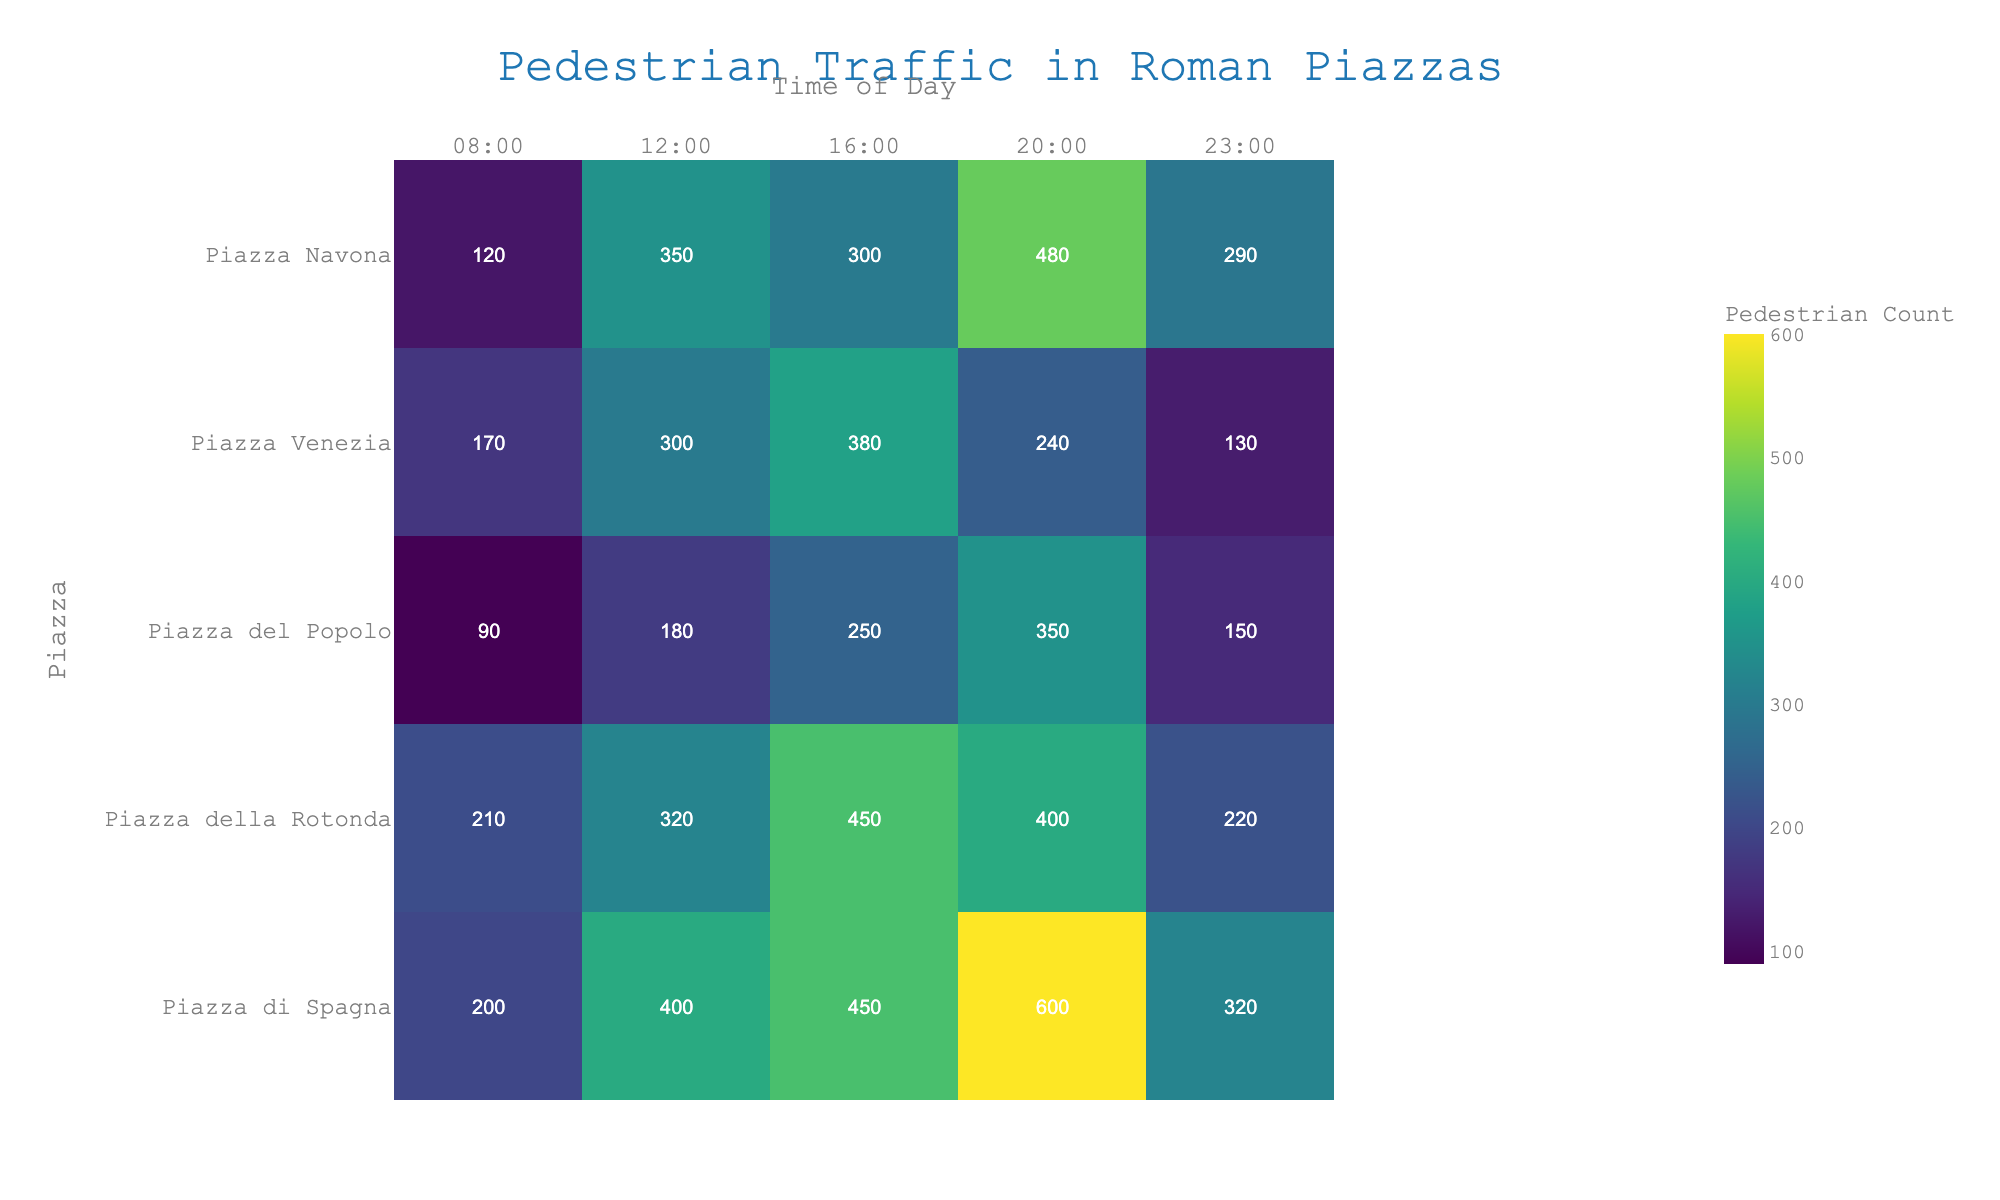What is the pedestrian count in Piazza Navona at 12:00? Look at the intersection of the row for Piazza Navona and the column for 12:00 in the heatmap.
Answer: 350 Which piazza has the highest pedestrian count at 20:00? Compare the values in the column for 20:00 across all piazzas. The highest value is 600 at Piazza di Spagna.
Answer: Piazza di Spagna What is the difference in pedestrian count between Piazza Navona and Piazza Venezia at 16:00? Subtract the pedestrian count of Piazza Venezia from Piazza Navona at 16:00 (300 - 380).
Answer: -80 Which piazza has the lowest pedestrian count at 08:00? Look for the smallest value in the column for 08:00. The lowest value is 90 at Piazza del Popolo.
Answer: Piazza del Popolo What is the average pedestrian count in Piazza della Rotonda throughout the day? Add up all the counts for Piazza della Rotonda and divide by the number of time points (210 + 320 + 450 + 400 + 220) / 5.
Answer: 320 How does the pedestrian count in Piazza Navona change from 08:00 to 23:00? Observe the pedestrian counts in Piazza Navona at each time point from 08:00 to 23:00 (120, 350, 300, 480, 290). Note the increases and decreases.
Answer: increases, then decreases At what time is the pedestrian count highest in Piazza del Popolo? Look at the values for Piazza del Popolo and identify the highest one, which is at 20:00.
Answer: 20:00 Which piazza has the most consistent pedestrian traffic throughout the day? Compare the variation in pedestrian counts for each piazza. The least variation is seen in Piazza del Popolo (90 - 350).
Answer: Piazza del Popolo 